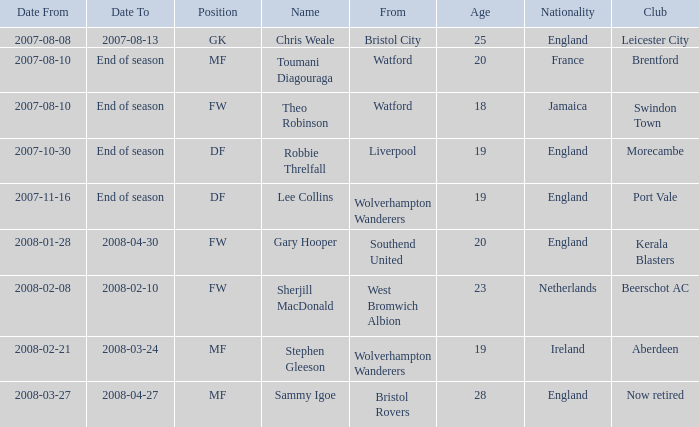What was the name for the row with Date From of 2008-02-21? Stephen Gleeson. 